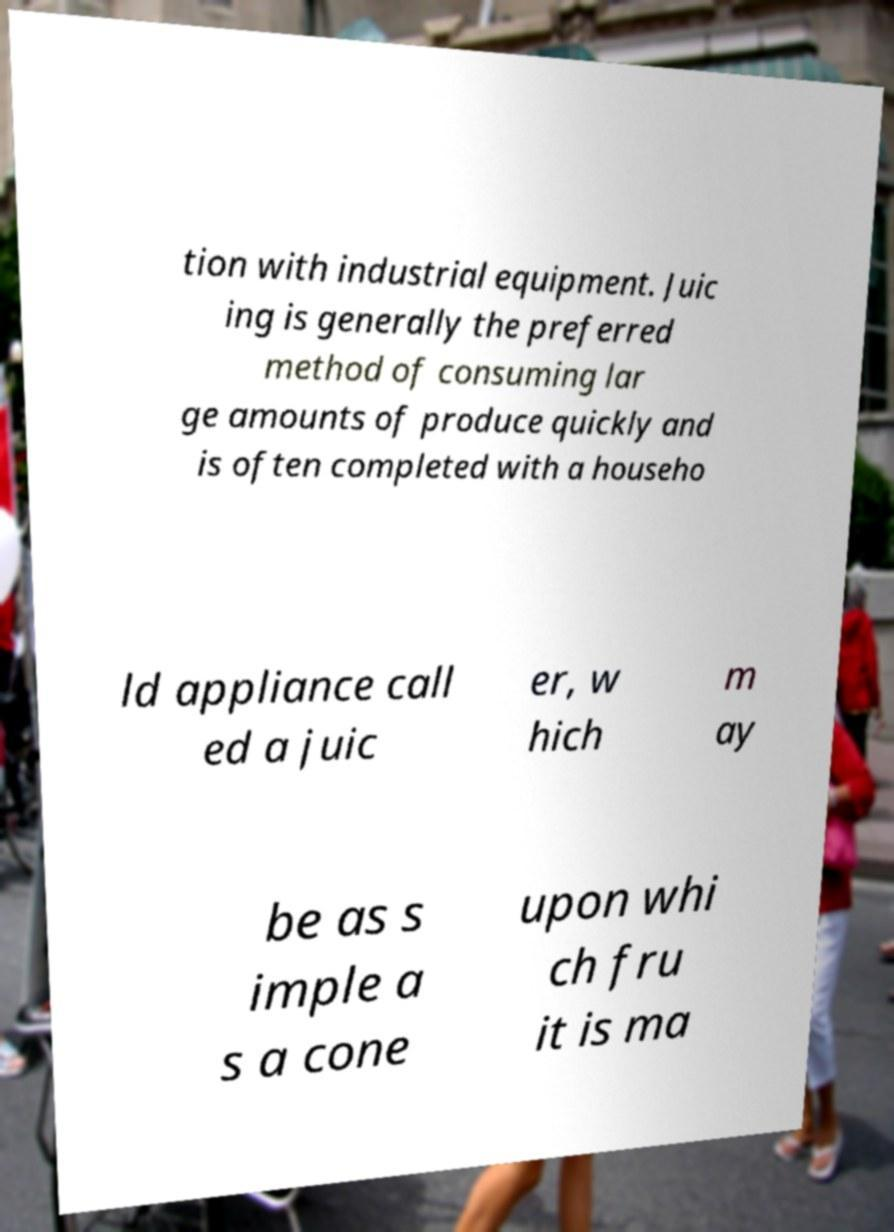I need the written content from this picture converted into text. Can you do that? tion with industrial equipment. Juic ing is generally the preferred method of consuming lar ge amounts of produce quickly and is often completed with a househo ld appliance call ed a juic er, w hich m ay be as s imple a s a cone upon whi ch fru it is ma 